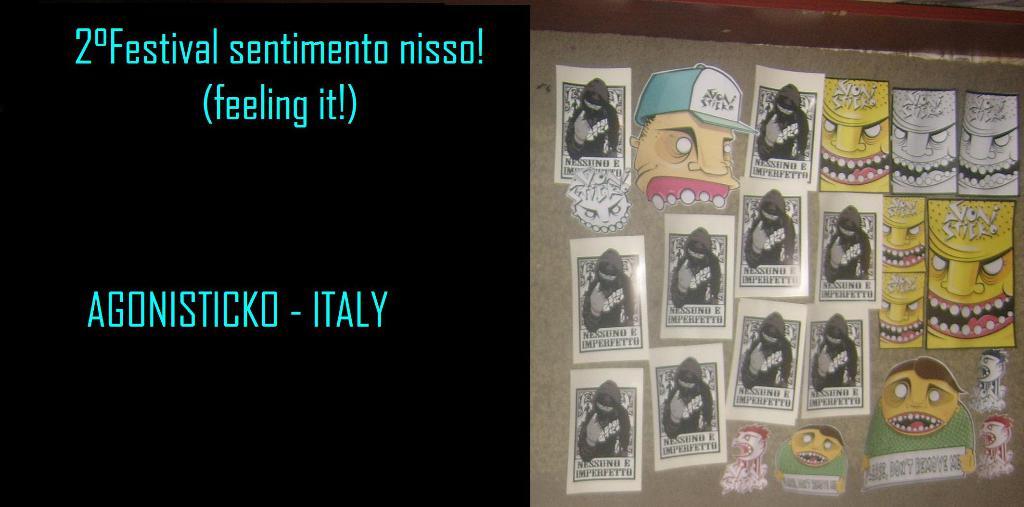What country is mentioned?
Ensure brevity in your answer.  Italy. 